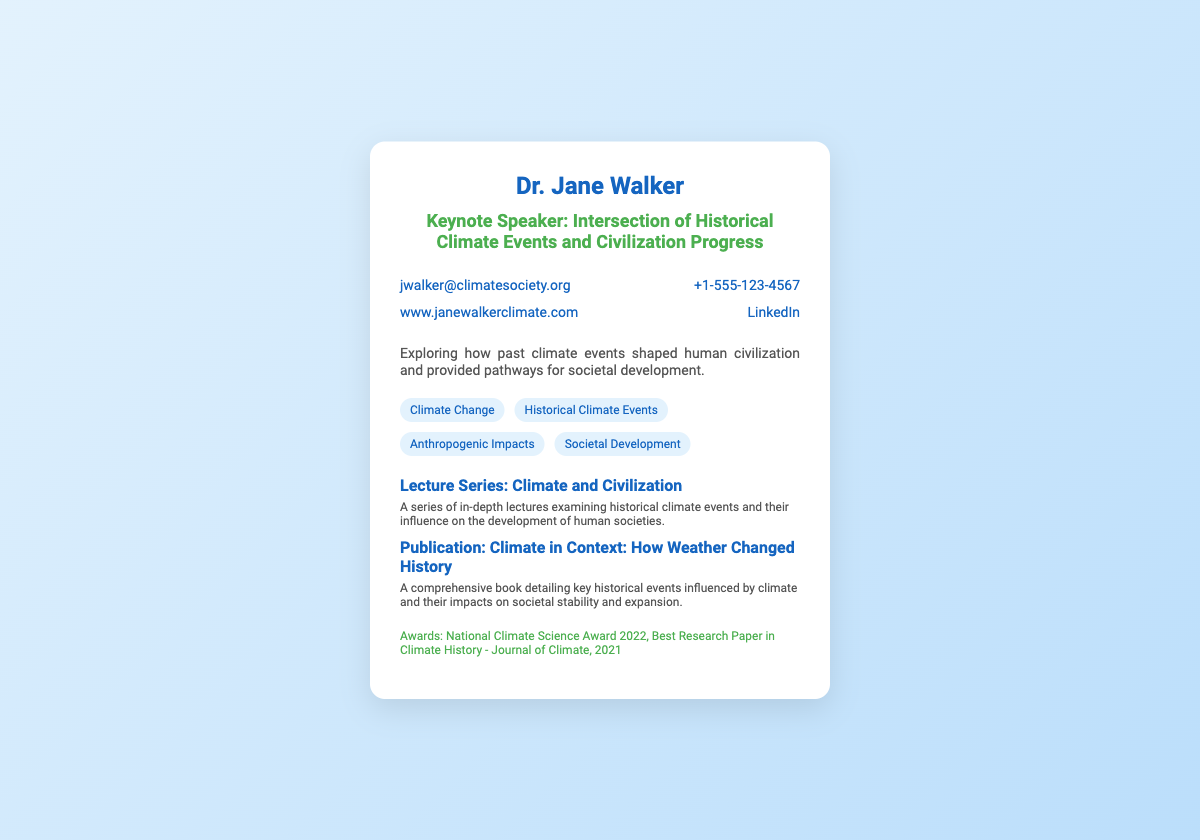What is the name of the keynote speaker? The name of the keynote speaker is prominently displayed at the top of the card.
Answer: Dr. Jane Walker What is the title of the keynote speech? The title of the keynote speech is located directly below the speaker's name.
Answer: Intersection of Historical Climate Events and Civilization Progress What is the email address of Dr. Jane Walker? The email address can be found in the contact section of the card.
Answer: jwalker@climatesociety.org What year did Dr. Jane Walker receive the National Climate Science Award? The year of the award is mentioned in the awards section of the card.
Answer: 2022 What is the title of Dr. Walker's publication? The title of the publication is highlighted in the list of highlights on the card.
Answer: Climate in Context: How Weather Changed History What two fields does Dr. Walker specialize in according to her expertise? The expertise section lists several areas of specialization to provide insight into her knowledge.
Answer: Climate Change, Historical Climate Events How many highlights are mentioned on the card? The highlights section provides two distinct items related to Dr. Walker's work.
Answer: 2 What is the phone number provided for Dr. Jane Walker? The phone number is listed in the contact section of the card for easy access.
Answer: +1-555-123-4567 What kind of series is Dr. Walker offering? The type of series is mentioned in the highlights section, indicating a focus on historical climate and society.
Answer: Lecture Series: Climate and Civilization 